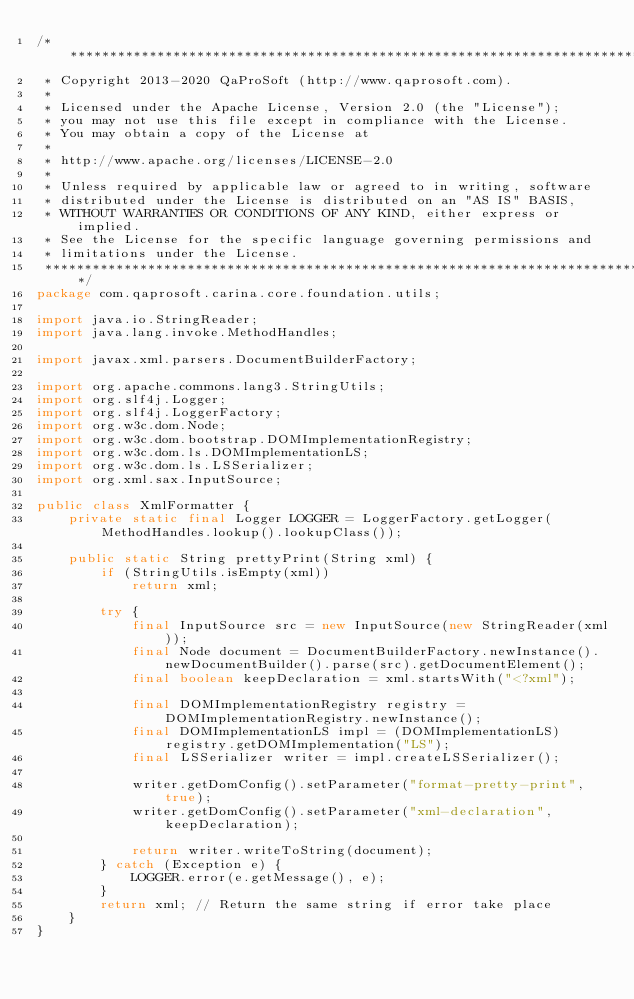Convert code to text. <code><loc_0><loc_0><loc_500><loc_500><_Java_>/*******************************************************************************
 * Copyright 2013-2020 QaProSoft (http://www.qaprosoft.com).
 *
 * Licensed under the Apache License, Version 2.0 (the "License");
 * you may not use this file except in compliance with the License.
 * You may obtain a copy of the License at
 *
 * http://www.apache.org/licenses/LICENSE-2.0
 *
 * Unless required by applicable law or agreed to in writing, software
 * distributed under the License is distributed on an "AS IS" BASIS,
 * WITHOUT WARRANTIES OR CONDITIONS OF ANY KIND, either express or implied.
 * See the License for the specific language governing permissions and
 * limitations under the License.
 *******************************************************************************/
package com.qaprosoft.carina.core.foundation.utils;

import java.io.StringReader;
import java.lang.invoke.MethodHandles;

import javax.xml.parsers.DocumentBuilderFactory;

import org.apache.commons.lang3.StringUtils;
import org.slf4j.Logger;
import org.slf4j.LoggerFactory;
import org.w3c.dom.Node;
import org.w3c.dom.bootstrap.DOMImplementationRegistry;
import org.w3c.dom.ls.DOMImplementationLS;
import org.w3c.dom.ls.LSSerializer;
import org.xml.sax.InputSource;

public class XmlFormatter {
    private static final Logger LOGGER = LoggerFactory.getLogger(MethodHandles.lookup().lookupClass());

    public static String prettyPrint(String xml) {
        if (StringUtils.isEmpty(xml))
            return xml;

        try {
            final InputSource src = new InputSource(new StringReader(xml));
            final Node document = DocumentBuilderFactory.newInstance().newDocumentBuilder().parse(src).getDocumentElement();
            final boolean keepDeclaration = xml.startsWith("<?xml");

            final DOMImplementationRegistry registry = DOMImplementationRegistry.newInstance();
            final DOMImplementationLS impl = (DOMImplementationLS) registry.getDOMImplementation("LS");
            final LSSerializer writer = impl.createLSSerializer();

            writer.getDomConfig().setParameter("format-pretty-print", true);
            writer.getDomConfig().setParameter("xml-declaration", keepDeclaration);

            return writer.writeToString(document);
        } catch (Exception e) {
            LOGGER.error(e.getMessage(), e);
        }
        return xml; // Return the same string if error take place
    }
}</code> 